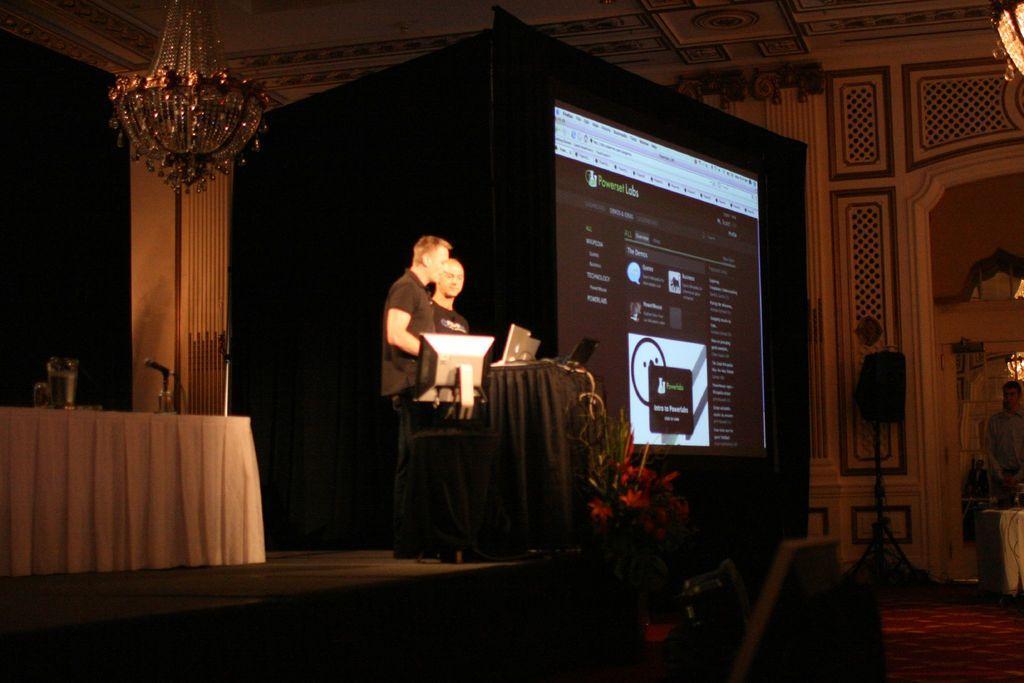Describe this image in one or two sentences. In the center of the image we can see one stage. On the stage, we can see two persons are standing. In front of them, we can see stands, one monitor, laptops, etc. In the background there is a wall, roof, table, cloth, microphone, plant, screen, lights and a few other objects. 